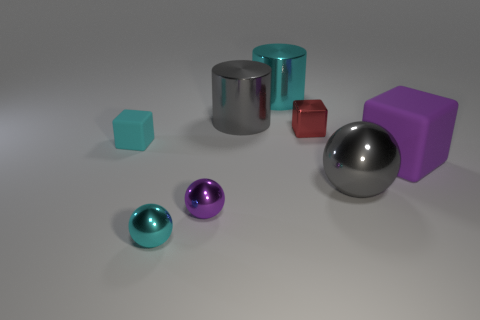Subtract all red blocks. How many blocks are left? 2 Add 1 small balls. How many objects exist? 9 Subtract 1 cylinders. How many cylinders are left? 1 Subtract all gray spheres. How many spheres are left? 2 Subtract all blocks. How many objects are left? 5 Subtract all green spheres. How many purple cylinders are left? 0 Add 3 big cubes. How many big cubes exist? 4 Subtract 0 blue cylinders. How many objects are left? 8 Subtract all yellow cubes. Subtract all green cylinders. How many cubes are left? 3 Subtract all blue matte things. Subtract all purple rubber objects. How many objects are left? 7 